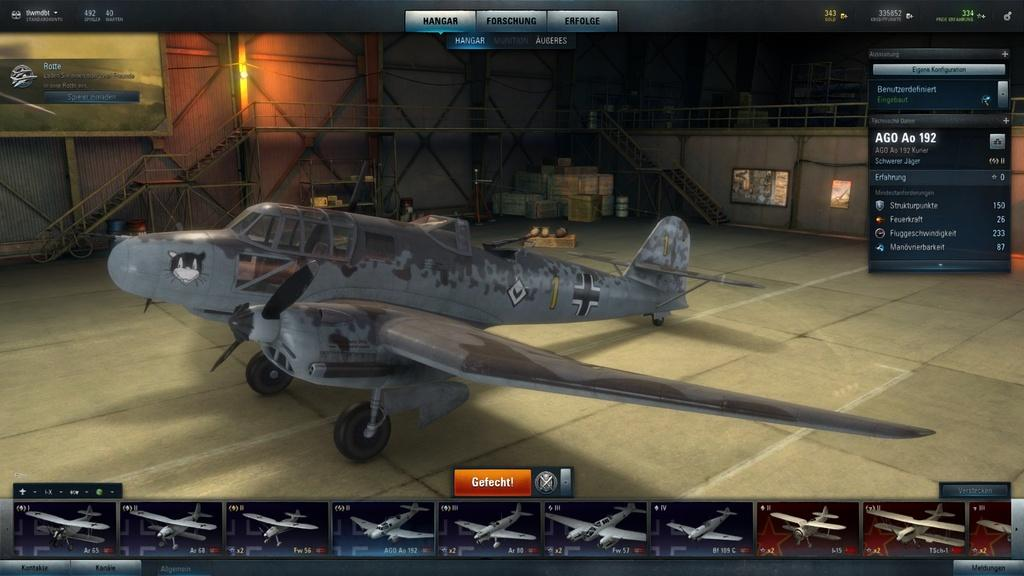<image>
Present a compact description of the photo's key features. An image of a gray airplane reads "Gefecht!" 